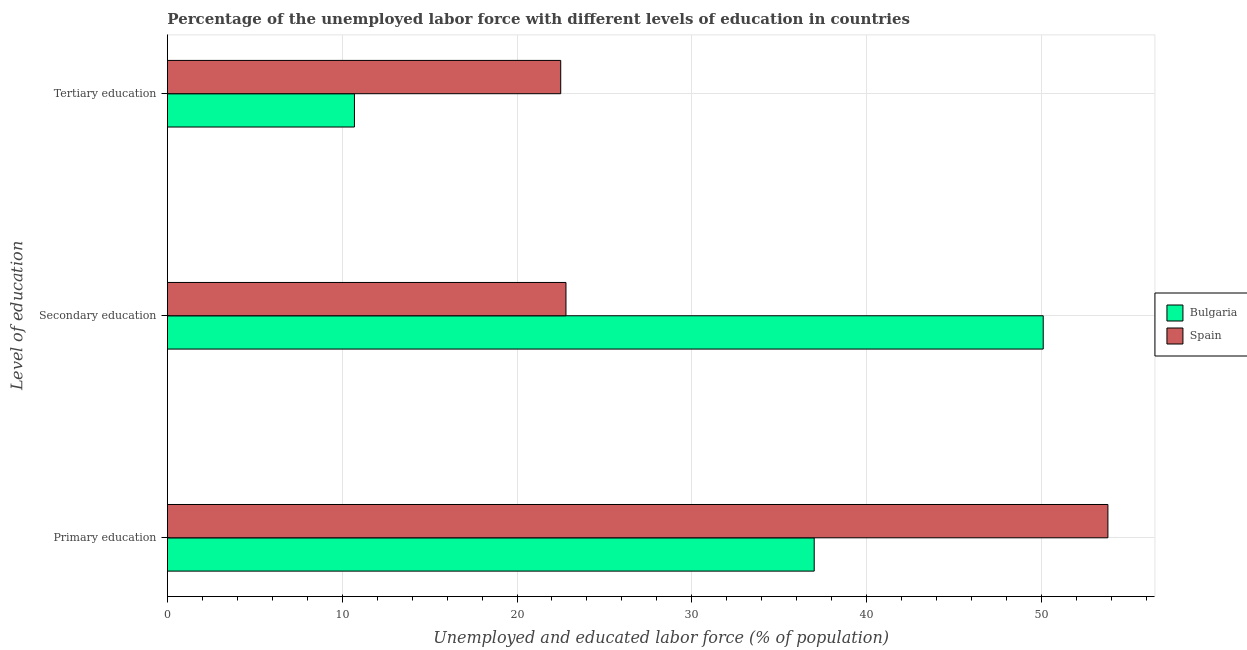How many different coloured bars are there?
Offer a very short reply. 2. How many bars are there on the 1st tick from the top?
Your answer should be compact. 2. How many bars are there on the 1st tick from the bottom?
Provide a succinct answer. 2. What is the label of the 2nd group of bars from the top?
Keep it short and to the point. Secondary education. What is the percentage of labor force who received primary education in Spain?
Offer a terse response. 53.8. Across all countries, what is the maximum percentage of labor force who received primary education?
Your answer should be very brief. 53.8. Across all countries, what is the minimum percentage of labor force who received primary education?
Your response must be concise. 37. What is the total percentage of labor force who received secondary education in the graph?
Give a very brief answer. 72.9. What is the difference between the percentage of labor force who received secondary education in Bulgaria and that in Spain?
Ensure brevity in your answer.  27.3. What is the average percentage of labor force who received tertiary education per country?
Your response must be concise. 16.6. What is the difference between the percentage of labor force who received primary education and percentage of labor force who received secondary education in Spain?
Offer a terse response. 31. What is the ratio of the percentage of labor force who received secondary education in Bulgaria to that in Spain?
Your response must be concise. 2.2. Is the percentage of labor force who received primary education in Bulgaria less than that in Spain?
Your response must be concise. Yes. Is the difference between the percentage of labor force who received secondary education in Spain and Bulgaria greater than the difference between the percentage of labor force who received tertiary education in Spain and Bulgaria?
Your response must be concise. No. What is the difference between the highest and the second highest percentage of labor force who received secondary education?
Make the answer very short. 27.3. What is the difference between the highest and the lowest percentage of labor force who received primary education?
Offer a very short reply. 16.8. In how many countries, is the percentage of labor force who received secondary education greater than the average percentage of labor force who received secondary education taken over all countries?
Offer a terse response. 1. What does the 1st bar from the top in Secondary education represents?
Offer a terse response. Spain. Is it the case that in every country, the sum of the percentage of labor force who received primary education and percentage of labor force who received secondary education is greater than the percentage of labor force who received tertiary education?
Make the answer very short. Yes. Are all the bars in the graph horizontal?
Your answer should be compact. Yes. How many countries are there in the graph?
Your answer should be very brief. 2. Are the values on the major ticks of X-axis written in scientific E-notation?
Provide a short and direct response. No. How many legend labels are there?
Make the answer very short. 2. How are the legend labels stacked?
Offer a terse response. Vertical. What is the title of the graph?
Offer a terse response. Percentage of the unemployed labor force with different levels of education in countries. What is the label or title of the X-axis?
Your answer should be compact. Unemployed and educated labor force (% of population). What is the label or title of the Y-axis?
Keep it short and to the point. Level of education. What is the Unemployed and educated labor force (% of population) of Bulgaria in Primary education?
Keep it short and to the point. 37. What is the Unemployed and educated labor force (% of population) in Spain in Primary education?
Your response must be concise. 53.8. What is the Unemployed and educated labor force (% of population) of Bulgaria in Secondary education?
Your answer should be compact. 50.1. What is the Unemployed and educated labor force (% of population) in Spain in Secondary education?
Your answer should be very brief. 22.8. What is the Unemployed and educated labor force (% of population) of Bulgaria in Tertiary education?
Make the answer very short. 10.7. Across all Level of education, what is the maximum Unemployed and educated labor force (% of population) of Bulgaria?
Your answer should be compact. 50.1. Across all Level of education, what is the maximum Unemployed and educated labor force (% of population) in Spain?
Your answer should be compact. 53.8. Across all Level of education, what is the minimum Unemployed and educated labor force (% of population) in Bulgaria?
Give a very brief answer. 10.7. What is the total Unemployed and educated labor force (% of population) of Bulgaria in the graph?
Offer a terse response. 97.8. What is the total Unemployed and educated labor force (% of population) of Spain in the graph?
Provide a short and direct response. 99.1. What is the difference between the Unemployed and educated labor force (% of population) in Spain in Primary education and that in Secondary education?
Your response must be concise. 31. What is the difference between the Unemployed and educated labor force (% of population) of Bulgaria in Primary education and that in Tertiary education?
Your response must be concise. 26.3. What is the difference between the Unemployed and educated labor force (% of population) of Spain in Primary education and that in Tertiary education?
Offer a terse response. 31.3. What is the difference between the Unemployed and educated labor force (% of population) in Bulgaria in Secondary education and that in Tertiary education?
Give a very brief answer. 39.4. What is the difference between the Unemployed and educated labor force (% of population) in Bulgaria in Primary education and the Unemployed and educated labor force (% of population) in Spain in Tertiary education?
Keep it short and to the point. 14.5. What is the difference between the Unemployed and educated labor force (% of population) of Bulgaria in Secondary education and the Unemployed and educated labor force (% of population) of Spain in Tertiary education?
Give a very brief answer. 27.6. What is the average Unemployed and educated labor force (% of population) of Bulgaria per Level of education?
Make the answer very short. 32.6. What is the average Unemployed and educated labor force (% of population) of Spain per Level of education?
Provide a succinct answer. 33.03. What is the difference between the Unemployed and educated labor force (% of population) in Bulgaria and Unemployed and educated labor force (% of population) in Spain in Primary education?
Offer a very short reply. -16.8. What is the difference between the Unemployed and educated labor force (% of population) in Bulgaria and Unemployed and educated labor force (% of population) in Spain in Secondary education?
Offer a terse response. 27.3. What is the difference between the Unemployed and educated labor force (% of population) of Bulgaria and Unemployed and educated labor force (% of population) of Spain in Tertiary education?
Your answer should be compact. -11.8. What is the ratio of the Unemployed and educated labor force (% of population) in Bulgaria in Primary education to that in Secondary education?
Provide a short and direct response. 0.74. What is the ratio of the Unemployed and educated labor force (% of population) in Spain in Primary education to that in Secondary education?
Provide a short and direct response. 2.36. What is the ratio of the Unemployed and educated labor force (% of population) of Bulgaria in Primary education to that in Tertiary education?
Your answer should be very brief. 3.46. What is the ratio of the Unemployed and educated labor force (% of population) of Spain in Primary education to that in Tertiary education?
Ensure brevity in your answer.  2.39. What is the ratio of the Unemployed and educated labor force (% of population) in Bulgaria in Secondary education to that in Tertiary education?
Offer a terse response. 4.68. What is the ratio of the Unemployed and educated labor force (% of population) in Spain in Secondary education to that in Tertiary education?
Offer a terse response. 1.01. What is the difference between the highest and the second highest Unemployed and educated labor force (% of population) in Bulgaria?
Offer a very short reply. 13.1. What is the difference between the highest and the second highest Unemployed and educated labor force (% of population) in Spain?
Your answer should be compact. 31. What is the difference between the highest and the lowest Unemployed and educated labor force (% of population) in Bulgaria?
Offer a very short reply. 39.4. What is the difference between the highest and the lowest Unemployed and educated labor force (% of population) in Spain?
Make the answer very short. 31.3. 